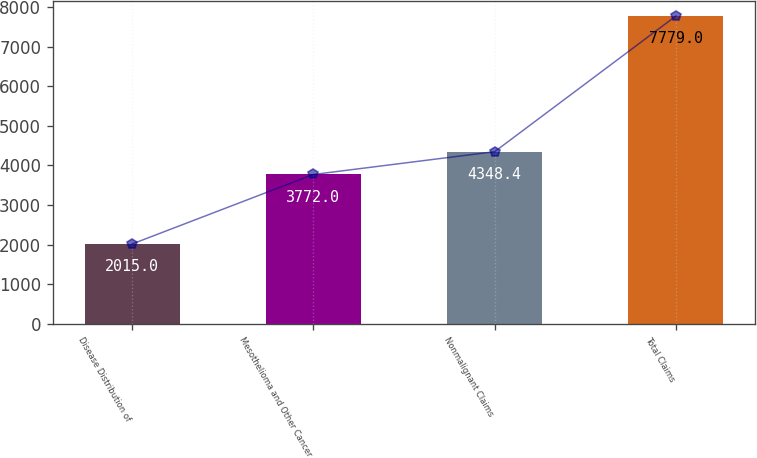Convert chart. <chart><loc_0><loc_0><loc_500><loc_500><bar_chart><fcel>Disease Distribution of<fcel>Mesothelioma and Other Cancer<fcel>Nonmalignant Claims<fcel>Total Claims<nl><fcel>2015<fcel>3772<fcel>4348.4<fcel>7779<nl></chart> 